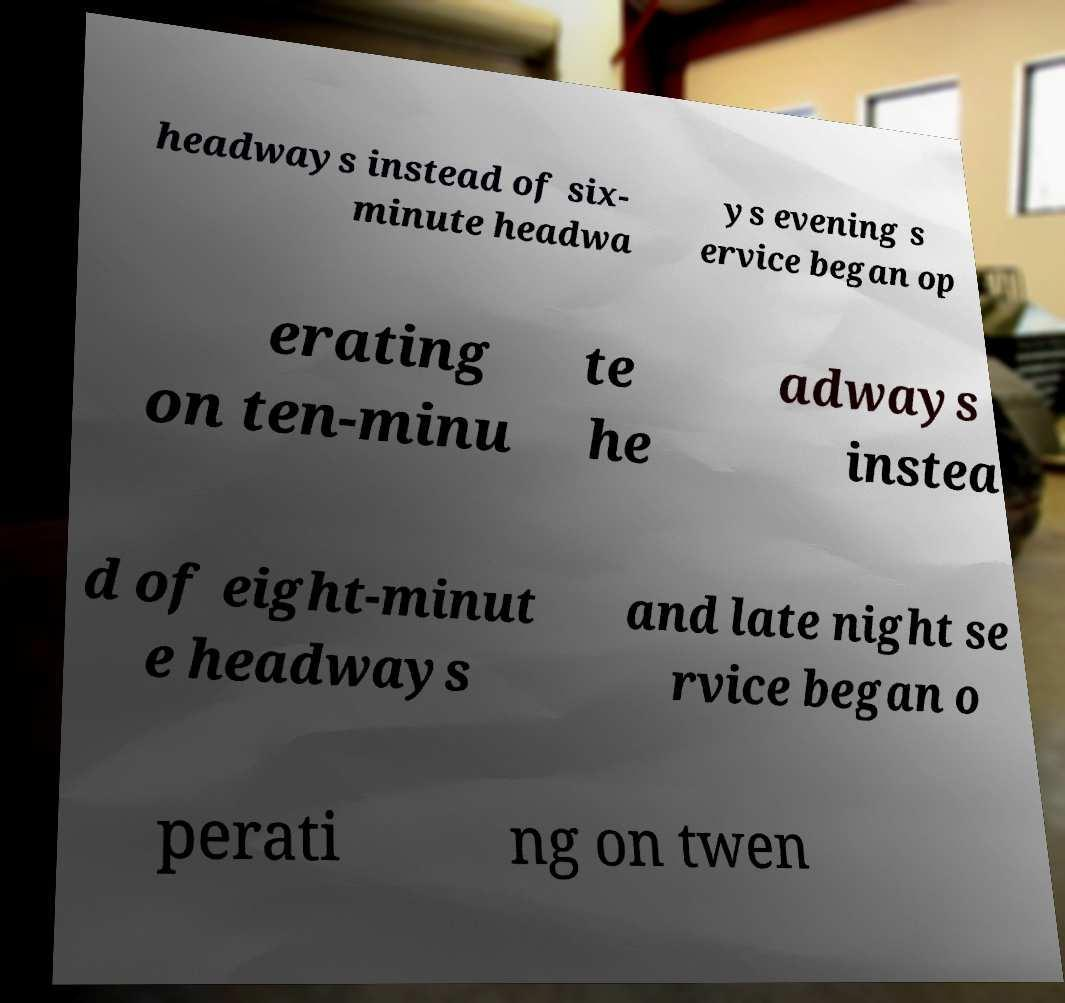Could you assist in decoding the text presented in this image and type it out clearly? headways instead of six- minute headwa ys evening s ervice began op erating on ten-minu te he adways instea d of eight-minut e headways and late night se rvice began o perati ng on twen 